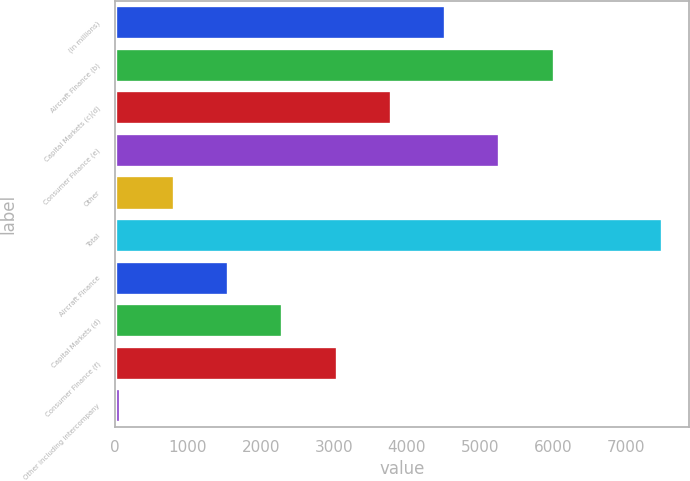Convert chart to OTSL. <chart><loc_0><loc_0><loc_500><loc_500><bar_chart><fcel>(in millions)<fcel>Aircraft Finance (b)<fcel>Capital Markets (c)(d)<fcel>Consumer Finance (e)<fcel>Other<fcel>Total<fcel>Aircraft Finance<fcel>Capital Markets (d)<fcel>Consumer Finance (f)<fcel>Other including intercompany<nl><fcel>4524.2<fcel>6009.6<fcel>3781.5<fcel>5266.9<fcel>810.7<fcel>7495<fcel>1553.4<fcel>2296.1<fcel>3038.8<fcel>68<nl></chart> 